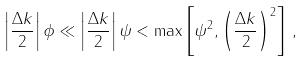<formula> <loc_0><loc_0><loc_500><loc_500>\left | \frac { \Delta k } { 2 } \right | \phi \ll \left | \frac { \Delta k } { 2 } \right | \psi < \max \left [ \psi ^ { 2 } , \left ( \frac { \Delta k } { 2 } \right ) ^ { 2 } \right ] \, ,</formula> 